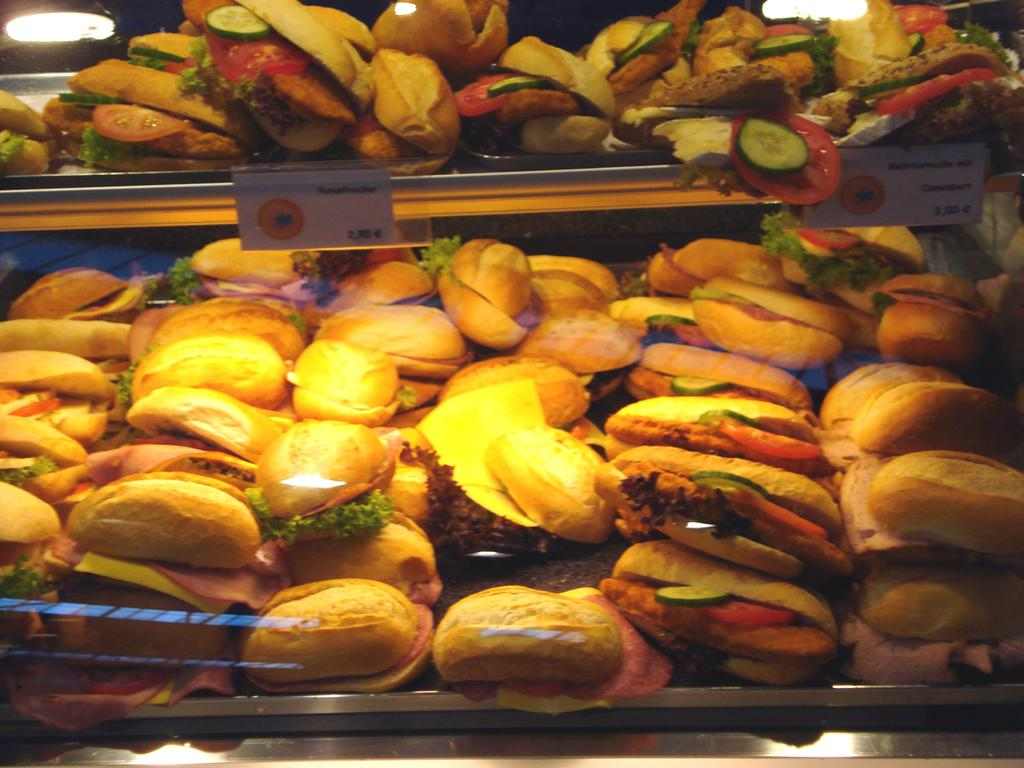What type of food can be seen in the image? There are burgers in the image. How are the burgers arranged or organized? The burgers are placed in racks. What type of drain is visible in the image? There is no drain present in the image; it features burgers placed in racks. How does the deer interact with the burgers in the image? There is no deer present in the image; it only features burgers placed in racks. 